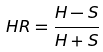Convert formula to latex. <formula><loc_0><loc_0><loc_500><loc_500>H R = \frac { H - S } { H + S }</formula> 